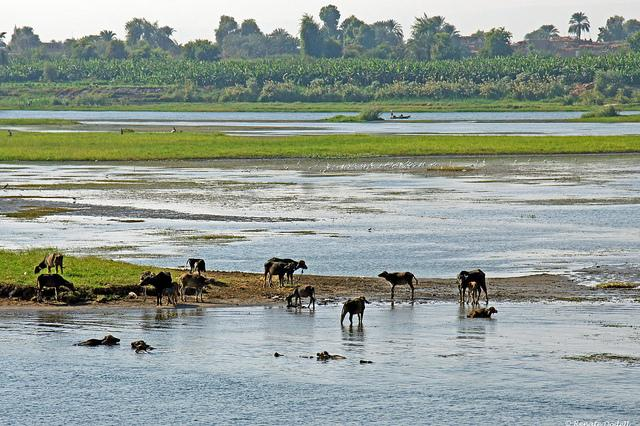What are the animals called?

Choices:
A) wildebeests
B) oxen
C) antelope
D) horses wildebeests 